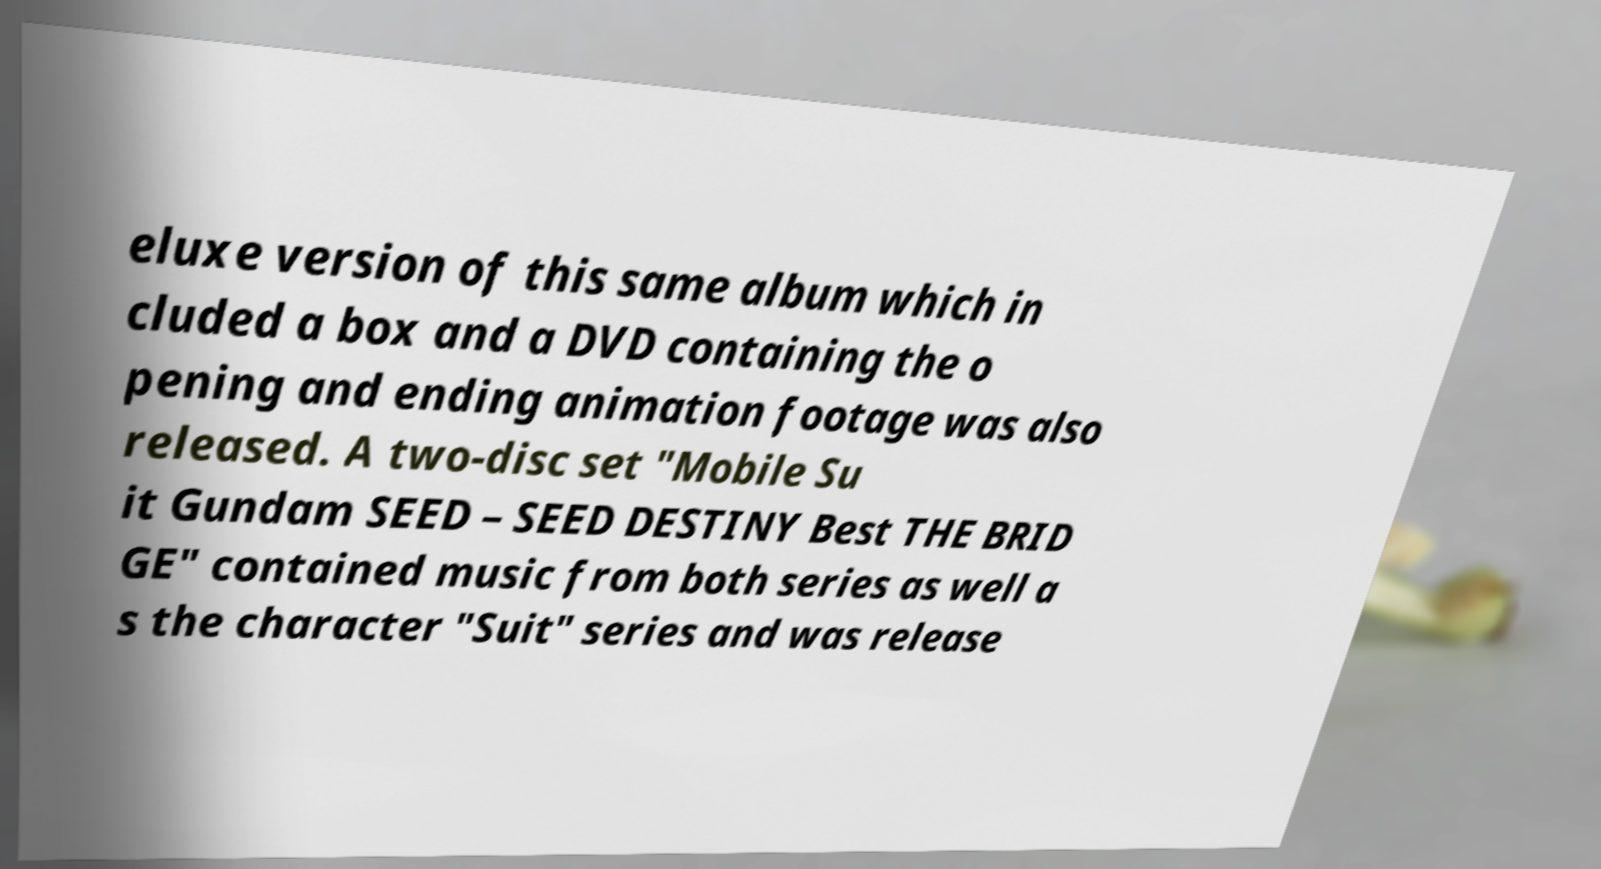Please read and relay the text visible in this image. What does it say? eluxe version of this same album which in cluded a box and a DVD containing the o pening and ending animation footage was also released. A two-disc set "Mobile Su it Gundam SEED – SEED DESTINY Best THE BRID GE" contained music from both series as well a s the character "Suit" series and was release 